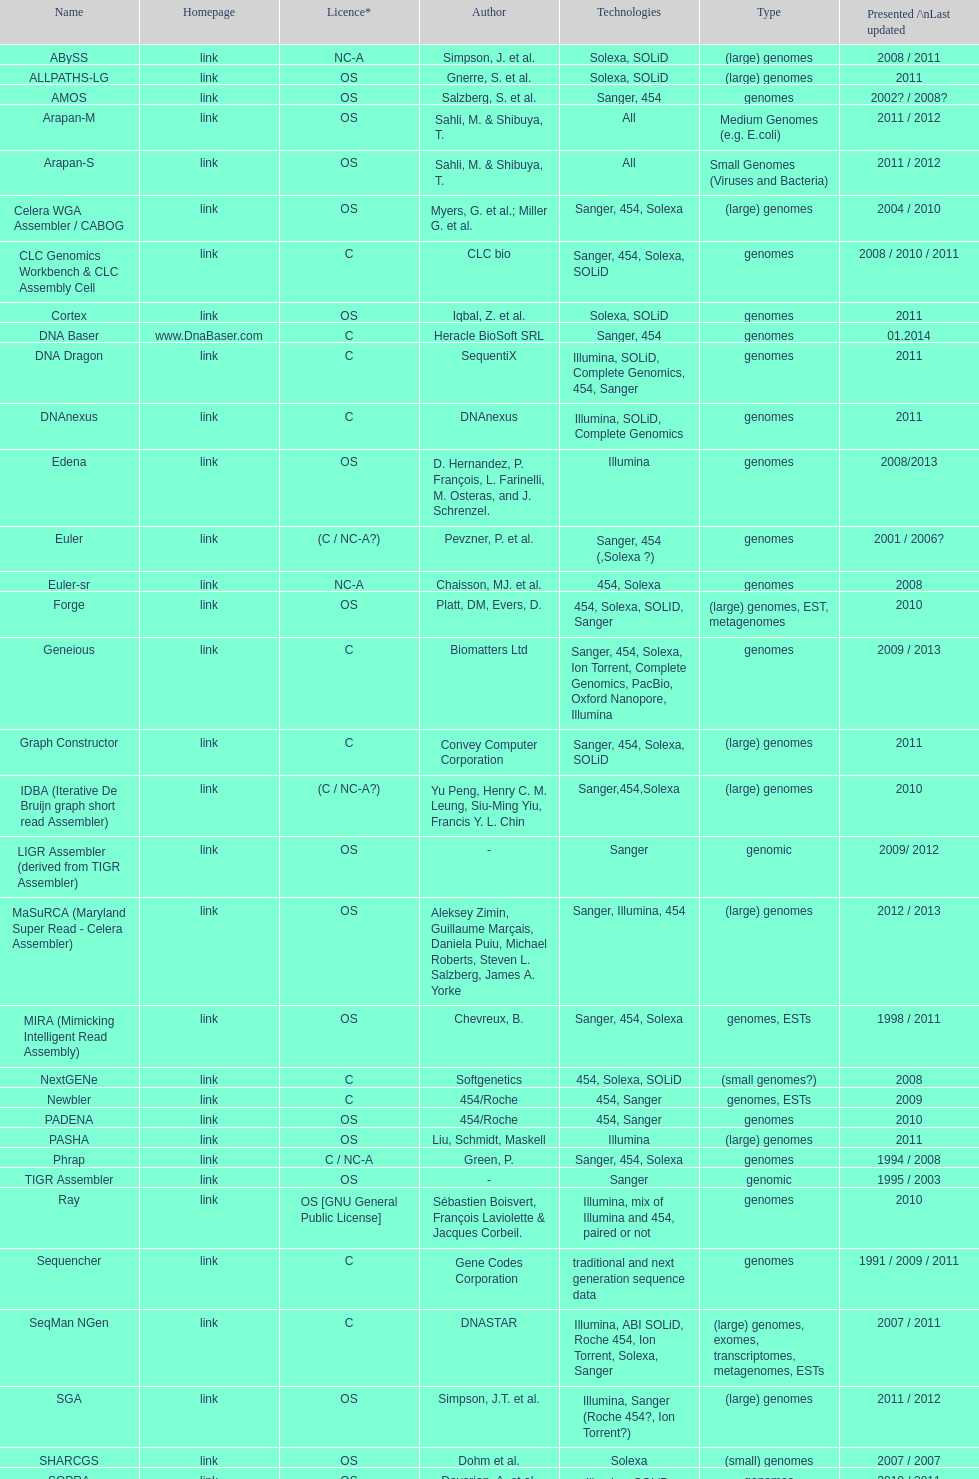How many assemblers are compatible with medium genome type technologies? 1. 